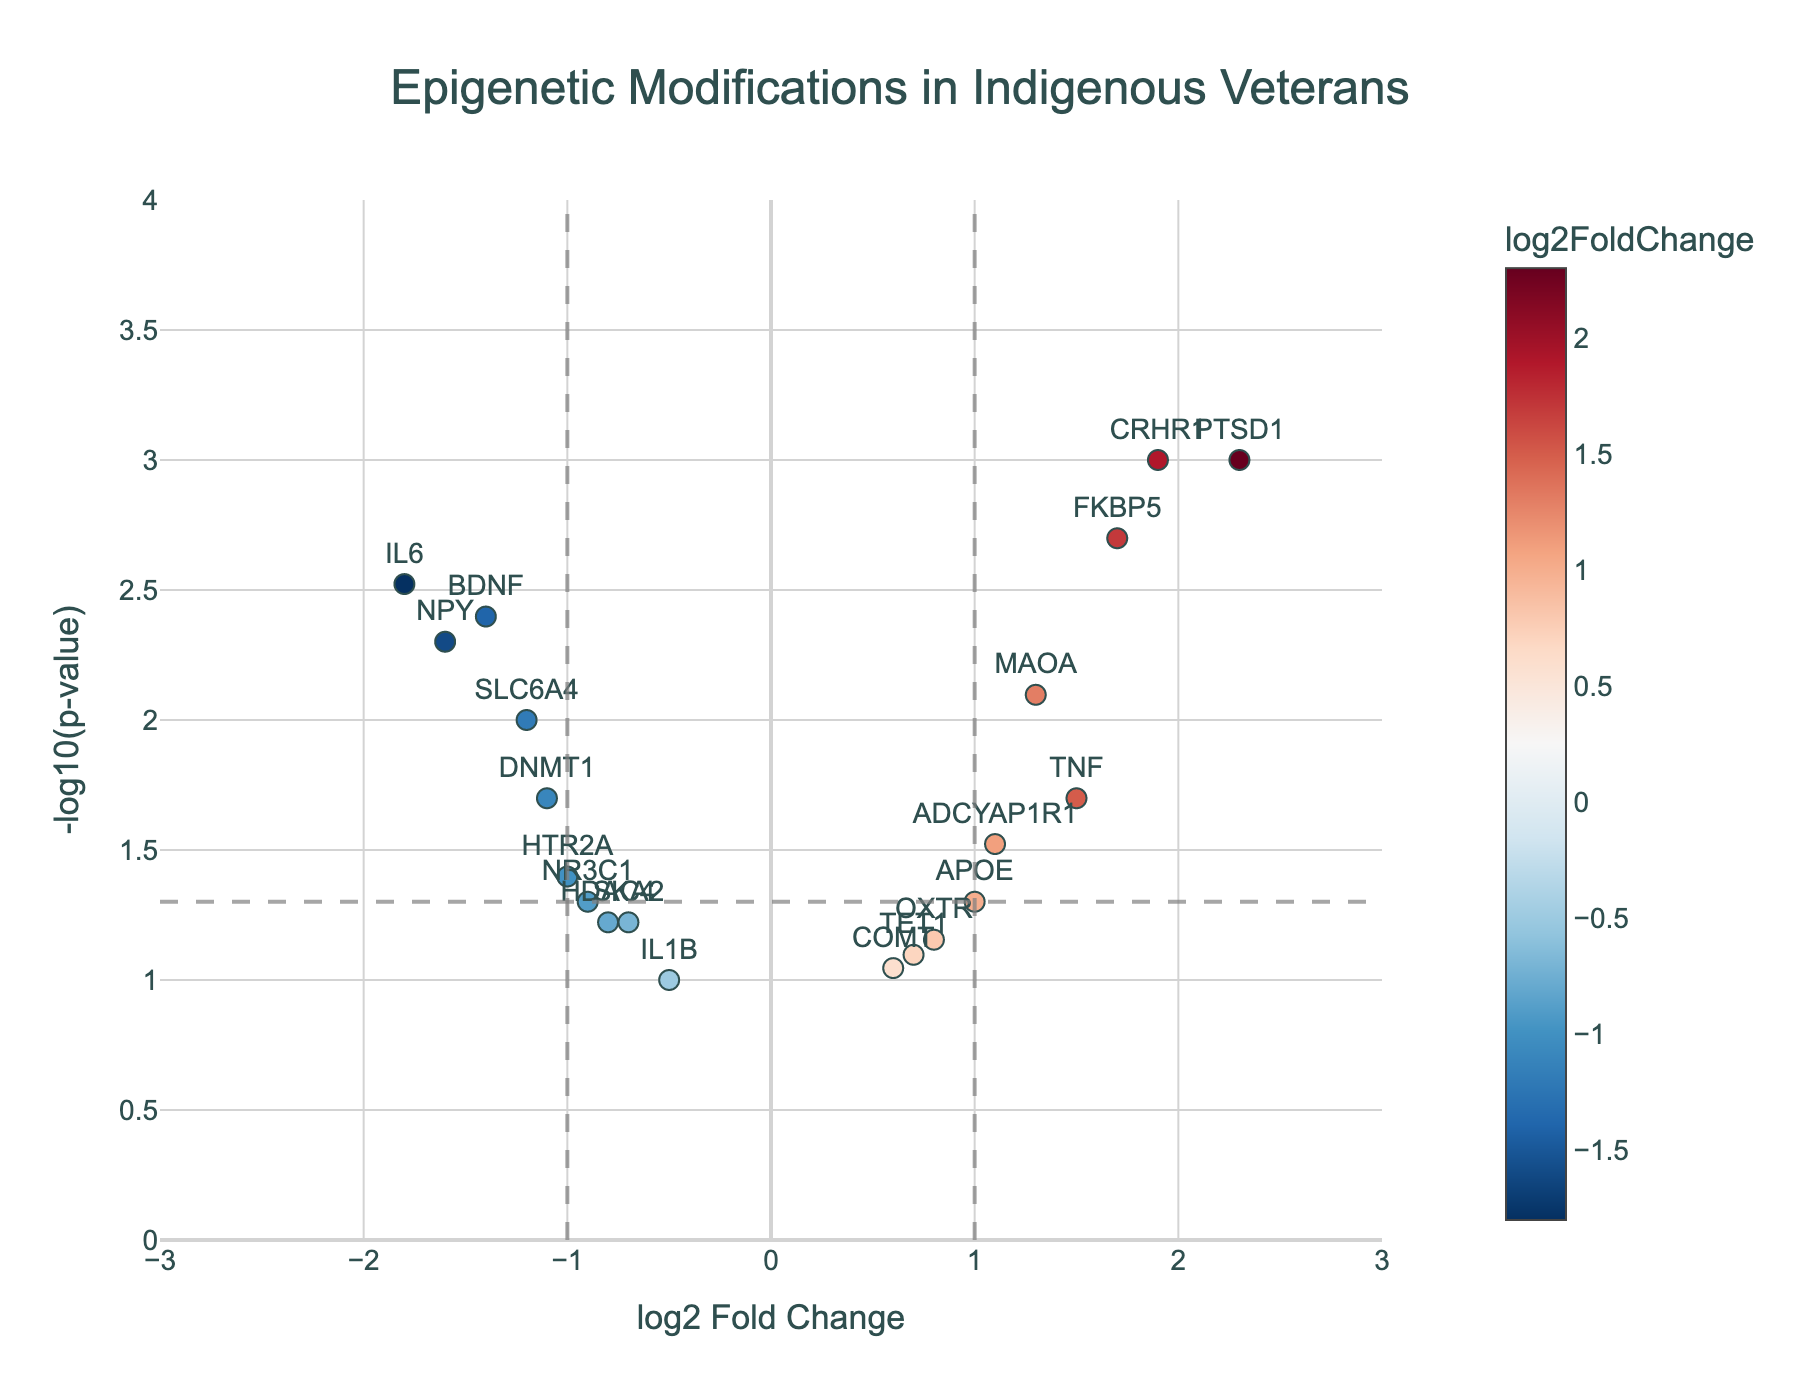What is the title of the figure? The title is usually found at the top of the figure and often gives a summary of what the plot is about. In this case, the title should summarize what the epigenetic modifications are among Indigenous veterans.
Answer: Epigenetic Modifications in Indigenous Veterans Which gene has the highest log2 fold change? By looking at the x-axis, we identify the gene with the rightmost data point as it represents the highest log2 fold change.
Answer: PTSD1 What is represented on the y-axis? The y-axis is labeled, and it indicates the value plotted vertically. Here, it is the negative log base 10 of the p-values.
Answer: -log10(p-value) Which gene is the most statistically significant and upregulated? When looking at statistical significance, we focus on p-values (y-axis), and for upregulation, we consider positive log2 fold change. The highest point with a positive x-value identifies the gene.
Answer: PTSD1 How many genes have a p-value less than 0.05? To find this, we look for data points above the horizontal gray dashed line in the figure, which marks -log10(0.05). Count these points.
Answer: Nine genes Which genes have a log2 fold change between -1 and 1 and are statistically significant? We need to identify genes between the vertical lines at x = -1 and x = 1 and above the horizontal dashed line marking statistical significance (-log10(0.05)).
Answer: BDNF, ADCYAP1R1 What is the range of log2 fold changes shown in the plot? Determine the minimum and maximum values on the x-axis, which represent the range of log2 fold changes.
Answer: -1.8 to 2.3 Are there more upregulated or downregulated genes with p-values less than 0.05? Compare the number of data points with positive log2 fold change (right of the vertical line at 0) and p-values less than 0.05 against those with negative log2 fold change (left of the vertical line at 0) and p-values less than 0.05.
Answer: More upregulated Which gene has the smallest p-value and is downregulated? The smallest p-value will be the highest point on the y-axis with a negative log2 fold change. Identify this gene.
Answer: IL6 